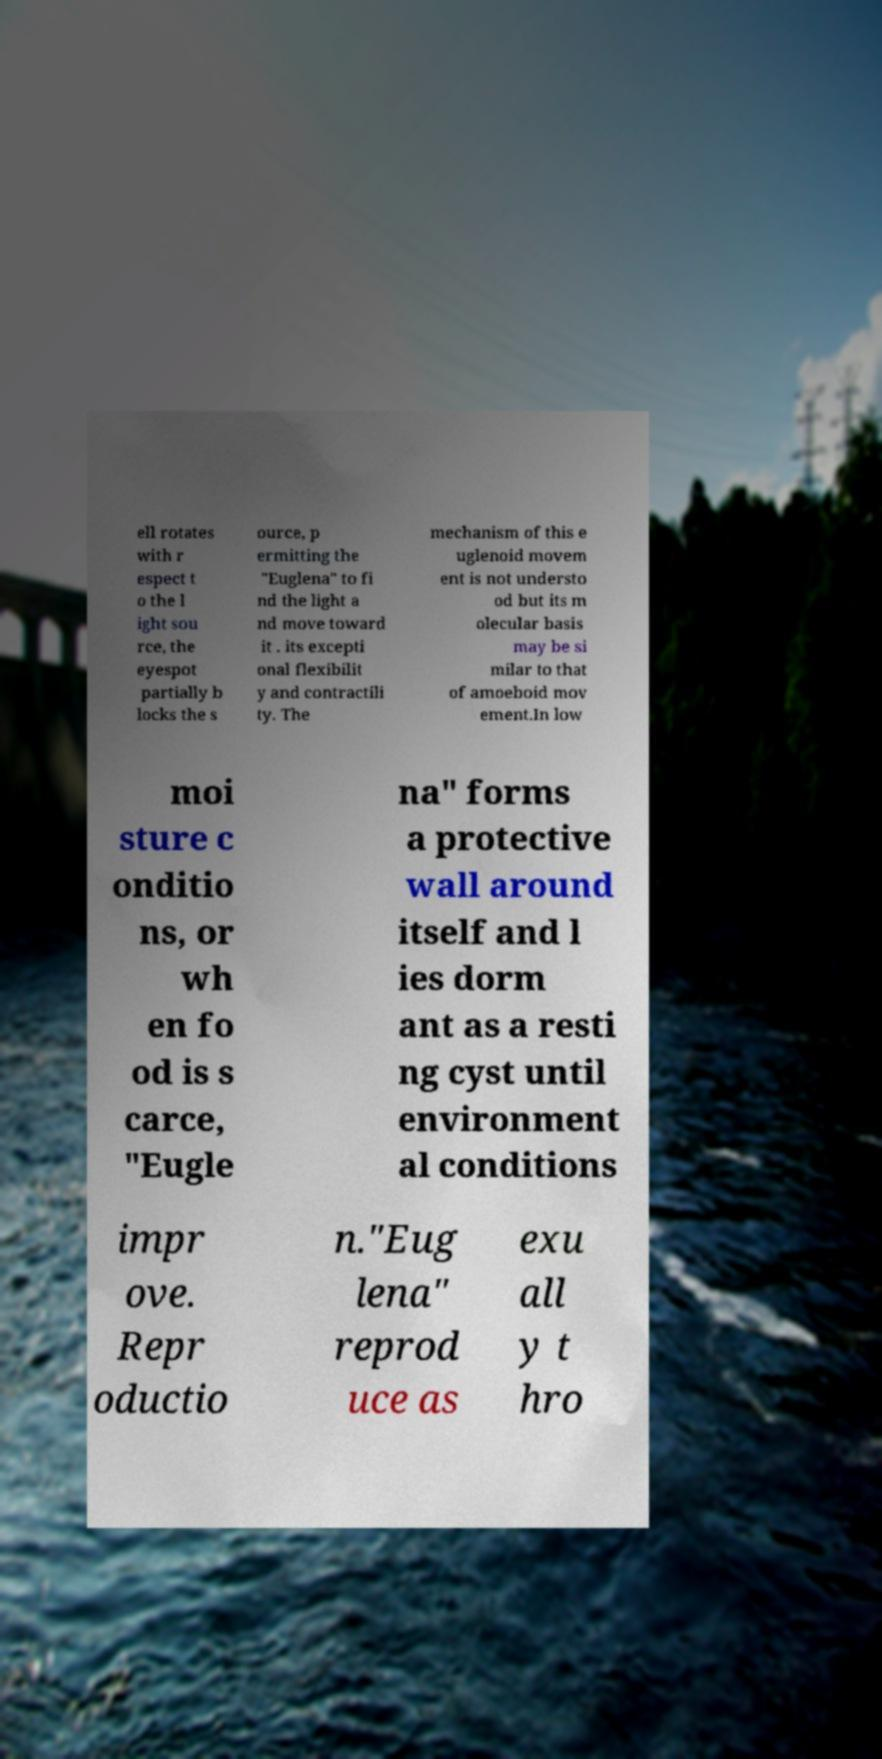Can you accurately transcribe the text from the provided image for me? ell rotates with r espect t o the l ight sou rce, the eyespot partially b locks the s ource, p ermitting the "Euglena" to fi nd the light a nd move toward it . its excepti onal flexibilit y and contractili ty. The mechanism of this e uglenoid movem ent is not understo od but its m olecular basis may be si milar to that of amoeboid mov ement.In low moi sture c onditio ns, or wh en fo od is s carce, "Eugle na" forms a protective wall around itself and l ies dorm ant as a resti ng cyst until environment al conditions impr ove. Repr oductio n."Eug lena" reprod uce as exu all y t hro 